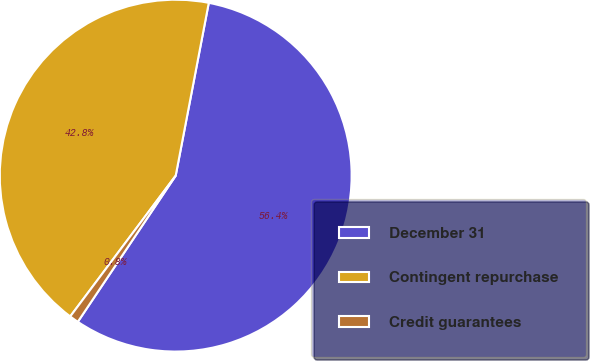Convert chart to OTSL. <chart><loc_0><loc_0><loc_500><loc_500><pie_chart><fcel>December 31<fcel>Contingent repurchase<fcel>Credit guarantees<nl><fcel>56.38%<fcel>42.78%<fcel>0.84%<nl></chart> 